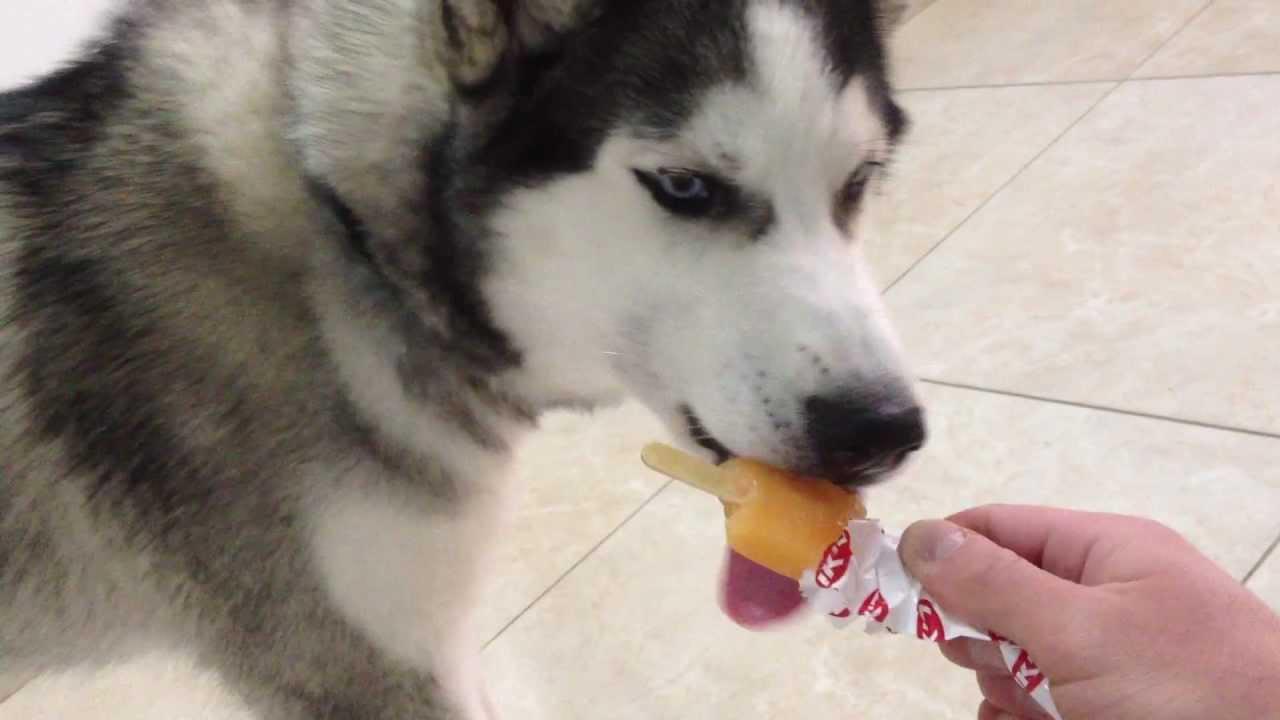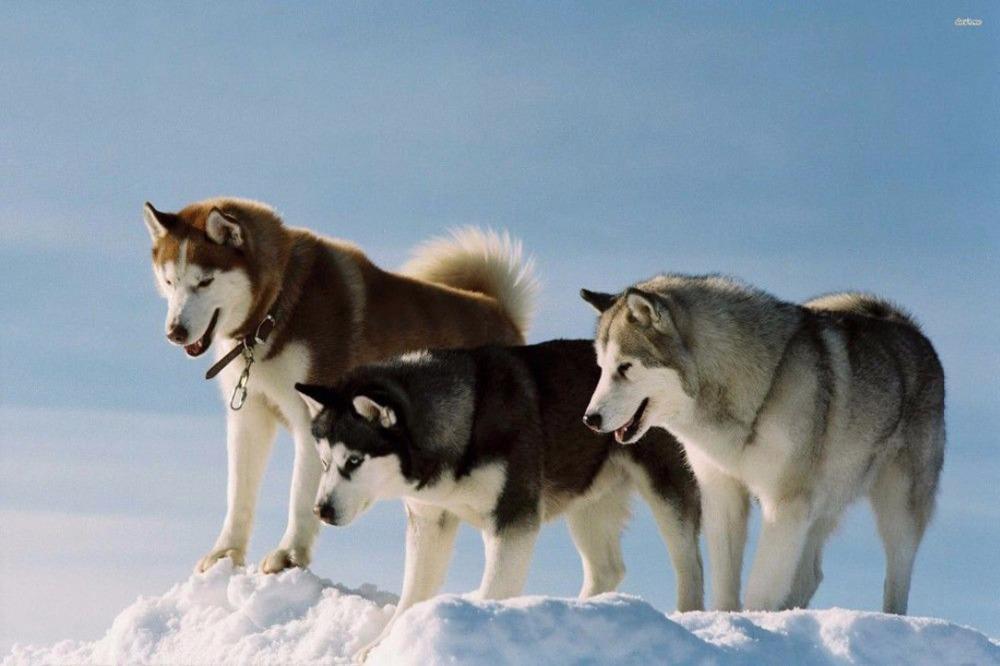The first image is the image on the left, the second image is the image on the right. Evaluate the accuracy of this statement regarding the images: "One of the treats is on a popsicle stick.". Is it true? Answer yes or no. Yes. The first image is the image on the left, the second image is the image on the right. Evaluate the accuracy of this statement regarding the images: "The left image shows  a hand offering white ice cream to a forward-facing husky dog.". Is it true? Answer yes or no. No. 